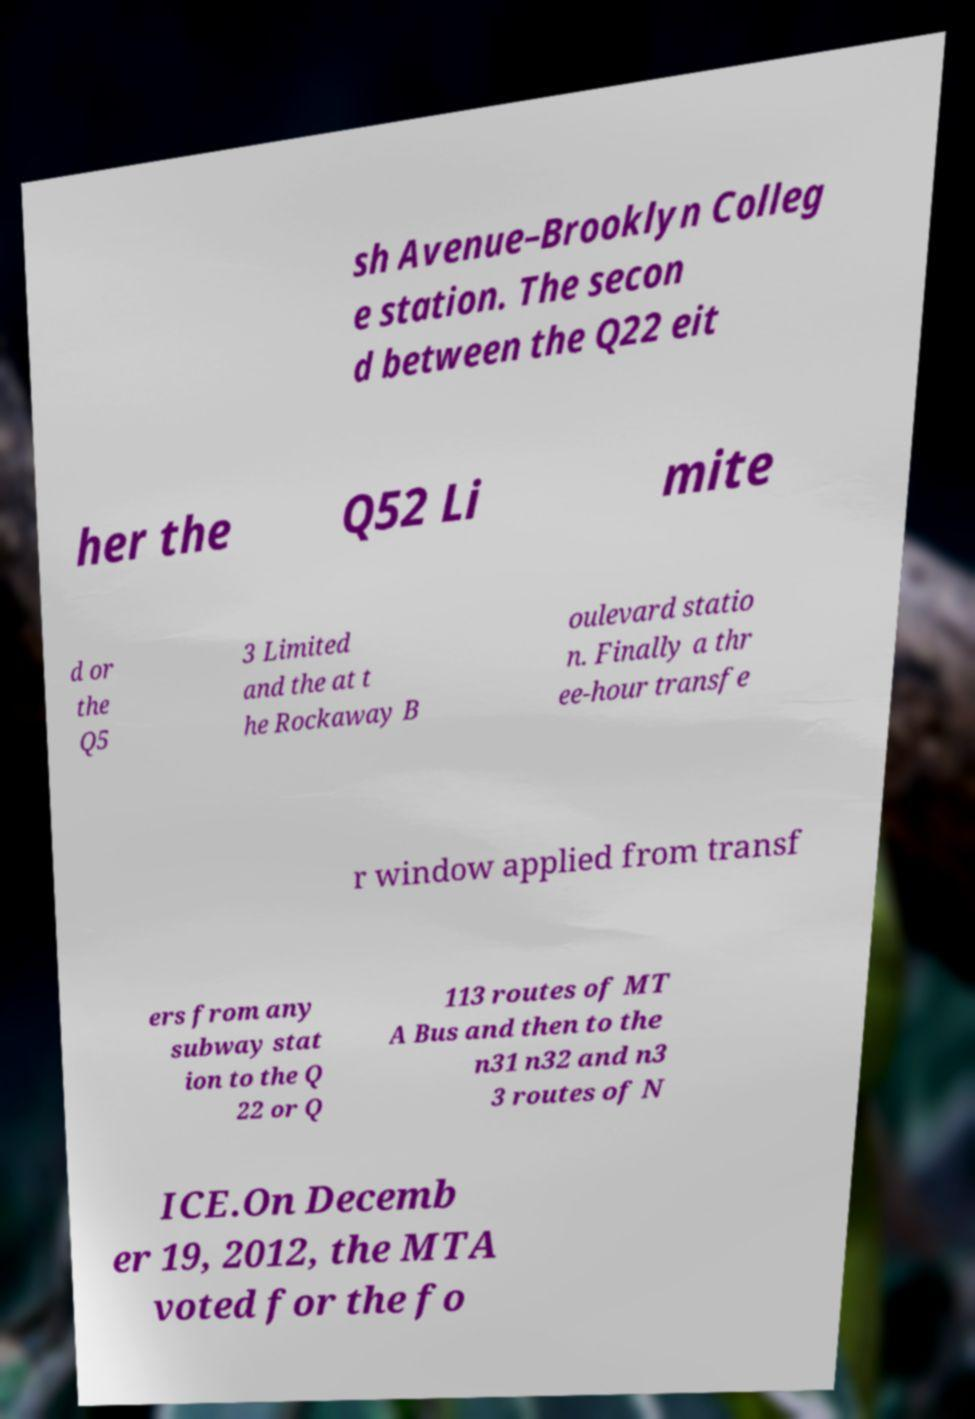Please identify and transcribe the text found in this image. sh Avenue–Brooklyn Colleg e station. The secon d between the Q22 eit her the Q52 Li mite d or the Q5 3 Limited and the at t he Rockaway B oulevard statio n. Finally a thr ee-hour transfe r window applied from transf ers from any subway stat ion to the Q 22 or Q 113 routes of MT A Bus and then to the n31 n32 and n3 3 routes of N ICE.On Decemb er 19, 2012, the MTA voted for the fo 